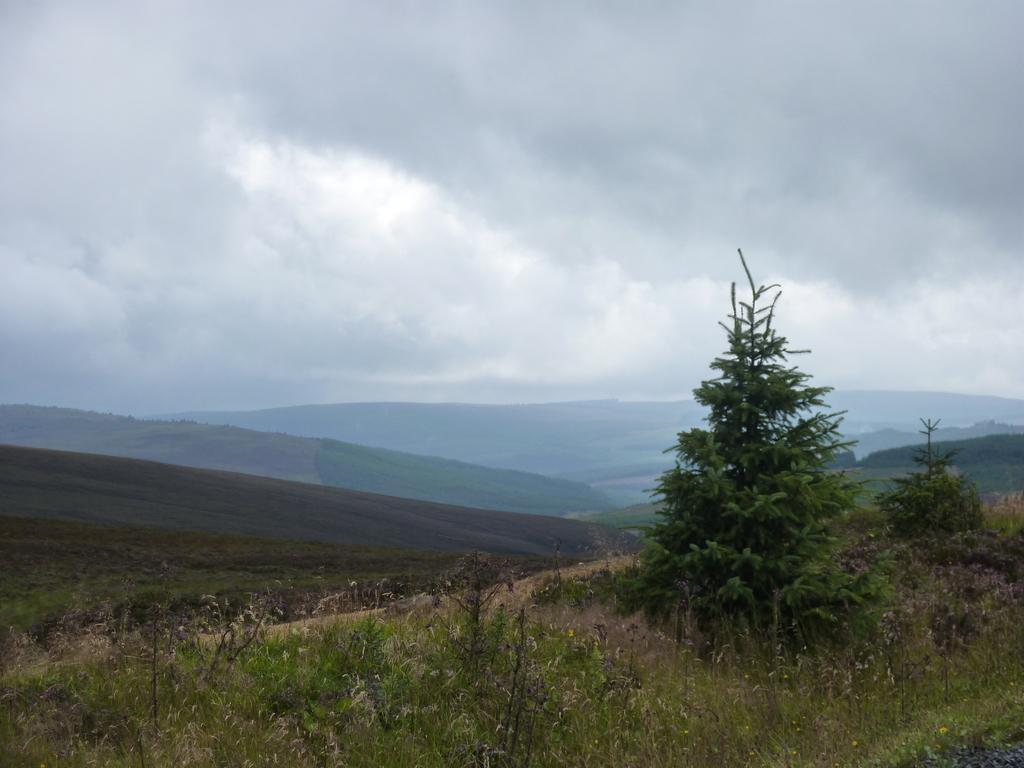Please provide a concise description of this image. In the image there is a tree in the front on the grassland and behind there are hills and above its sky with clouds. 